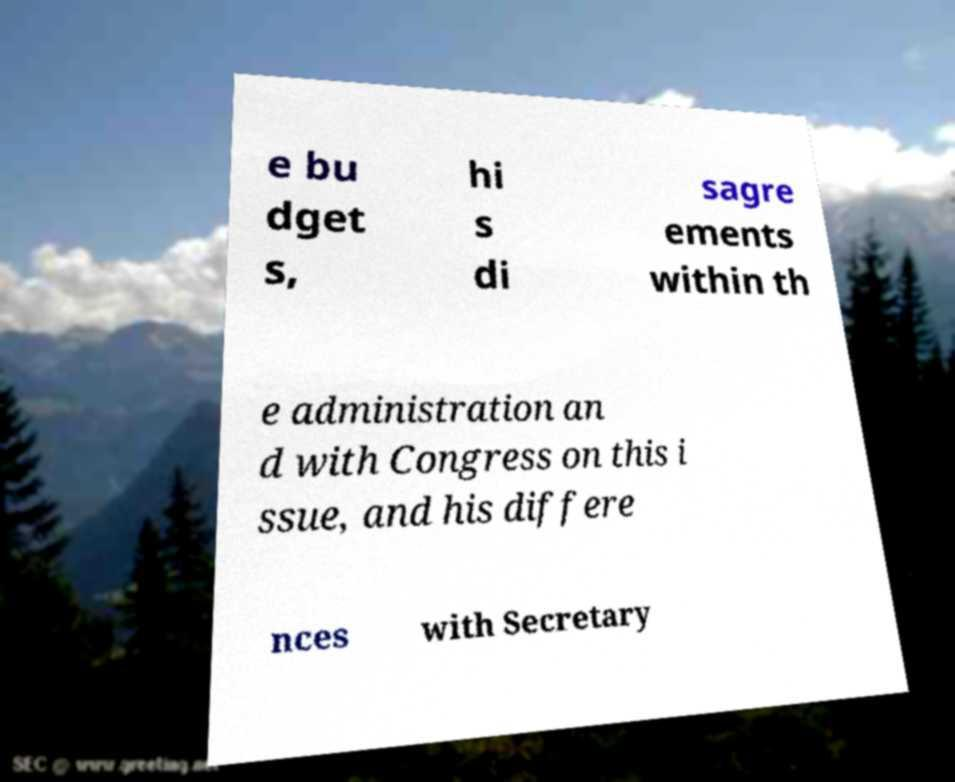I need the written content from this picture converted into text. Can you do that? e bu dget s, hi s di sagre ements within th e administration an d with Congress on this i ssue, and his differe nces with Secretary 